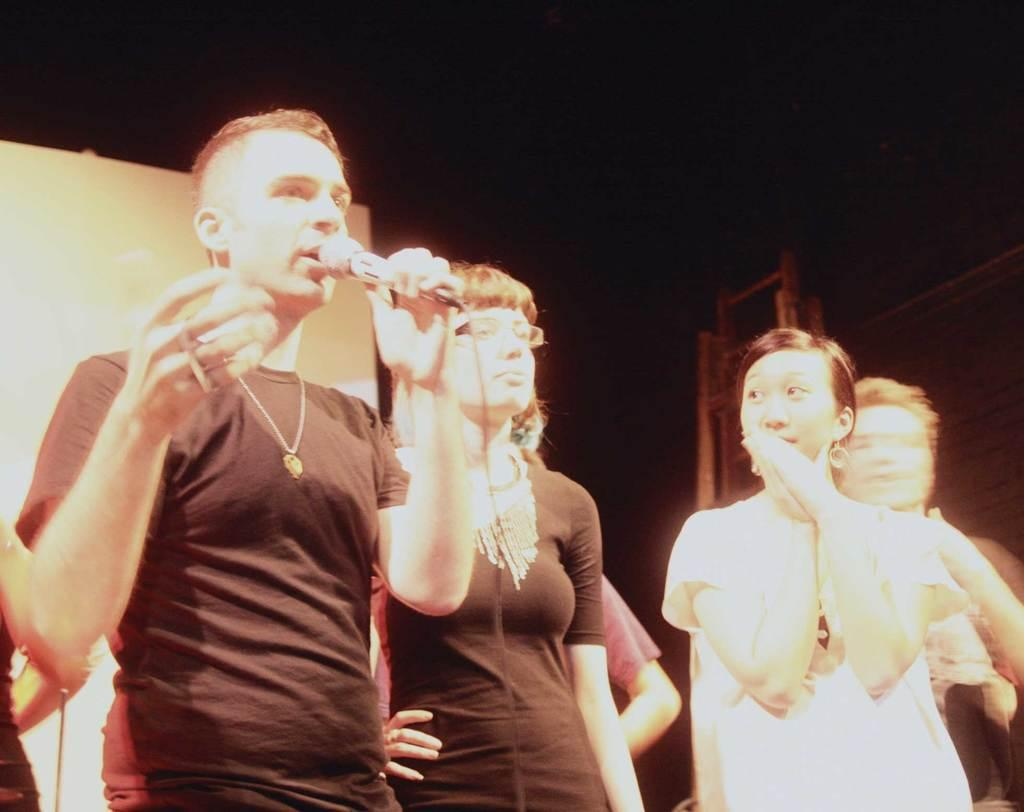How many people are in the image? There are people in the image, but the exact number is not specified. What is the person on the left side of the image holding? The person on the left side of the image is holding a microphone. What can be seen in the background of the image? There is a wall in the background of the image. What type of approval is the expert seeking in the image? There is no mention of an expert or approval in the image. The image only shows people, one of whom is holding a microphone, and a wall in the background. 